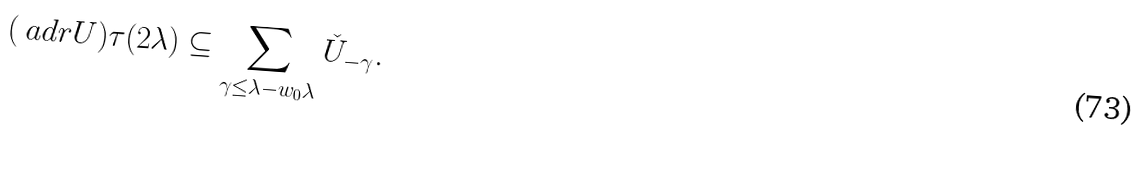<formula> <loc_0><loc_0><loc_500><loc_500>( \ a d r U ) \tau ( 2 \lambda ) \subseteq \sum _ { \gamma \leq \lambda - w _ { 0 } \lambda } \check { U } _ { - \gamma } .</formula> 